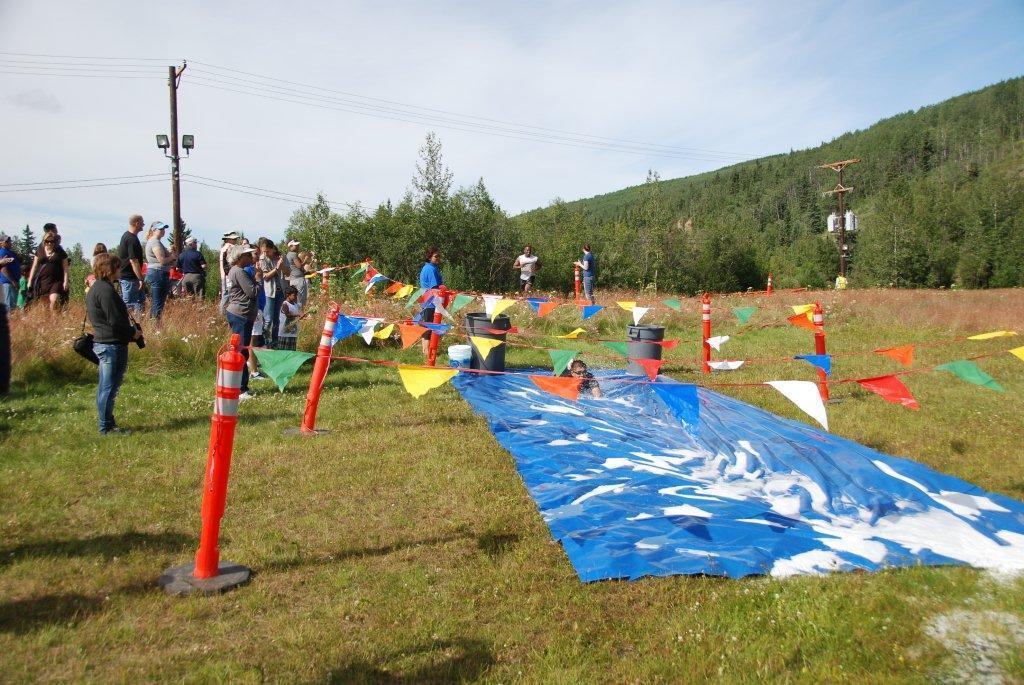Can you describe this image briefly? In this image we can see people are standing on the grassy land. There is a blue color sheet on the land. We can see flags are attached to orange color poles. In the background, we can see electric poles, wire and trees. At the top of the image, there is the sky. 